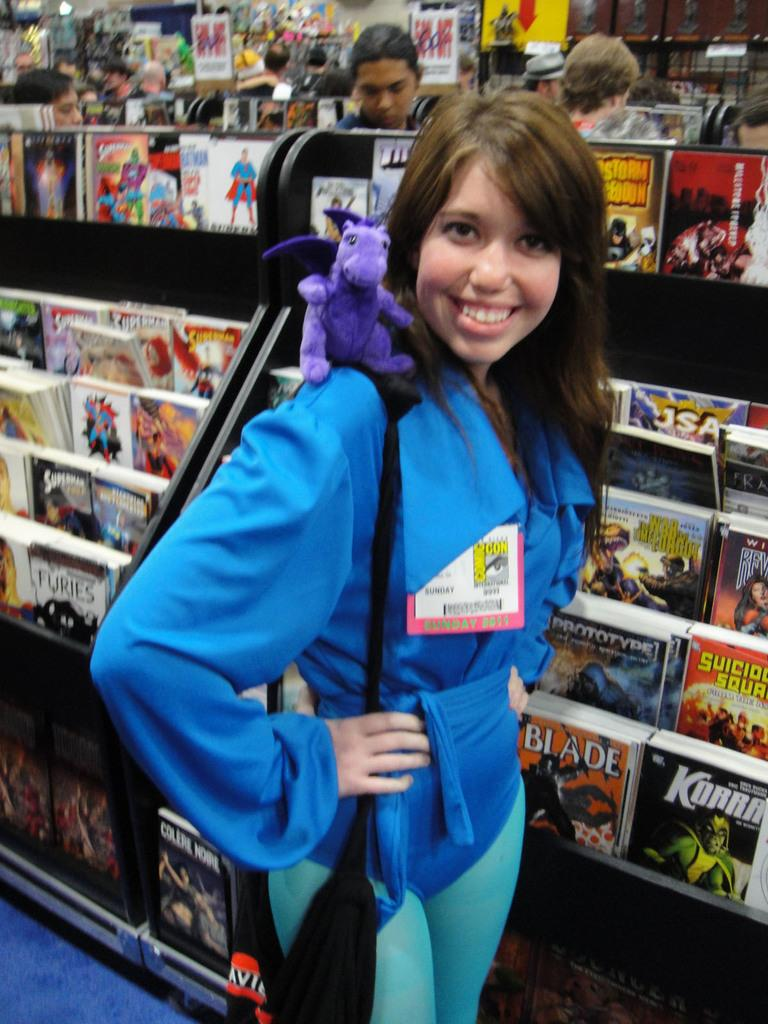What is the main subject in the foreground of the picture? There is a woman in the foreground of the picture. What can be seen in the middle of the picture? There are people, bookshelves, books, and other objects in the middle of the picture. What is visible in the background of the picture? There are posters, books, and people in the background of the picture. What type of cracker is being used as a bookmark in the image? There is no cracker present in the image, and therefore no such use can be observed. 